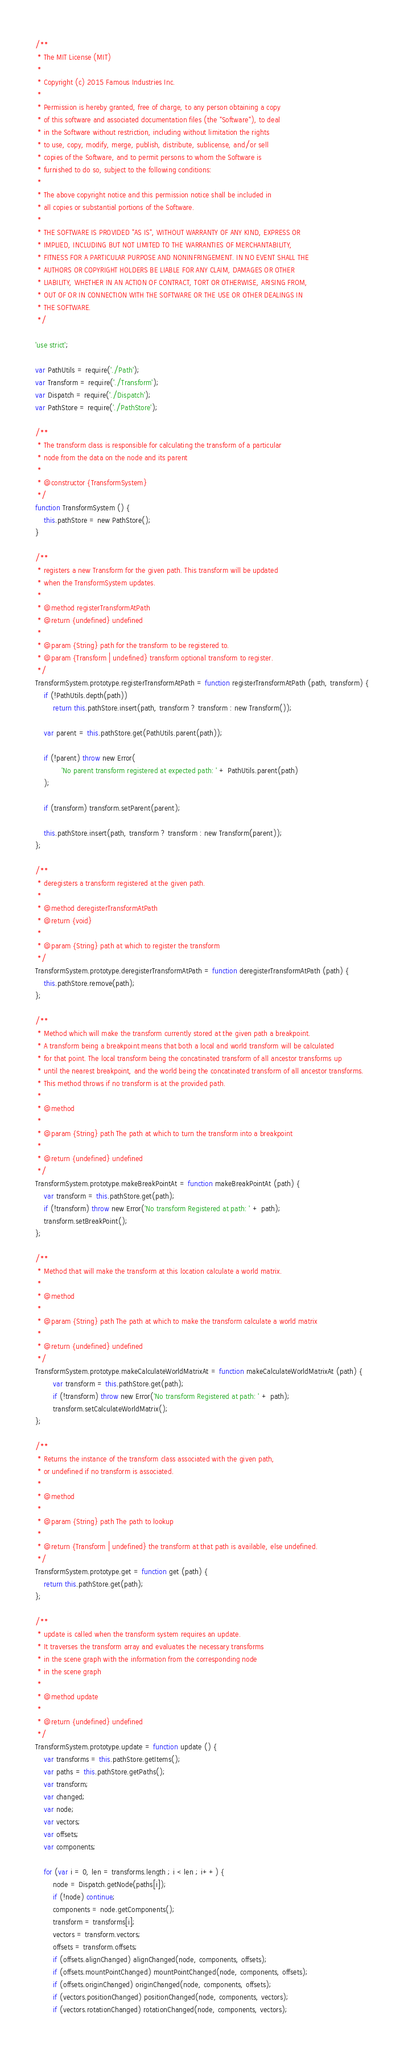<code> <loc_0><loc_0><loc_500><loc_500><_JavaScript_>/**
 * The MIT License (MIT)
 * 
 * Copyright (c) 2015 Famous Industries Inc.
 * 
 * Permission is hereby granted, free of charge, to any person obtaining a copy
 * of this software and associated documentation files (the "Software"), to deal
 * in the Software without restriction, including without limitation the rights
 * to use, copy, modify, merge, publish, distribute, sublicense, and/or sell
 * copies of the Software, and to permit persons to whom the Software is
 * furnished to do so, subject to the following conditions:
 * 
 * The above copyright notice and this permission notice shall be included in
 * all copies or substantial portions of the Software.
 * 
 * THE SOFTWARE IS PROVIDED "AS IS", WITHOUT WARRANTY OF ANY KIND, EXPRESS OR
 * IMPLIED, INCLUDING BUT NOT LIMITED TO THE WARRANTIES OF MERCHANTABILITY,
 * FITNESS FOR A PARTICULAR PURPOSE AND NONINFRINGEMENT. IN NO EVENT SHALL THE
 * AUTHORS OR COPYRIGHT HOLDERS BE LIABLE FOR ANY CLAIM, DAMAGES OR OTHER
 * LIABILITY, WHETHER IN AN ACTION OF CONTRACT, TORT OR OTHERWISE, ARISING FROM,
 * OUT OF OR IN CONNECTION WITH THE SOFTWARE OR THE USE OR OTHER DEALINGS IN
 * THE SOFTWARE.
 */

'use strict';

var PathUtils = require('./Path');
var Transform = require('./Transform');
var Dispatch = require('./Dispatch');
var PathStore = require('./PathStore');

/**
 * The transform class is responsible for calculating the transform of a particular
 * node from the data on the node and its parent
 *
 * @constructor {TransformSystem}
 */
function TransformSystem () {
    this.pathStore = new PathStore();
}

/**
 * registers a new Transform for the given path. This transform will be updated
 * when the TransformSystem updates.
 *
 * @method registerTransformAtPath
 * @return {undefined} undefined
 *
 * @param {String} path for the transform to be registered to.
 * @param {Transform | undefined} transform optional transform to register.
 */
TransformSystem.prototype.registerTransformAtPath = function registerTransformAtPath (path, transform) {
    if (!PathUtils.depth(path))
        return this.pathStore.insert(path, transform ? transform : new Transform());

    var parent = this.pathStore.get(PathUtils.parent(path));

    if (!parent) throw new Error(
            'No parent transform registered at expected path: ' + PathUtils.parent(path)
    );

    if (transform) transform.setParent(parent);

    this.pathStore.insert(path, transform ? transform : new Transform(parent));
};

/**
 * deregisters a transform registered at the given path.
 *
 * @method deregisterTransformAtPath
 * @return {void}
 *
 * @param {String} path at which to register the transform
 */
TransformSystem.prototype.deregisterTransformAtPath = function deregisterTransformAtPath (path) {
    this.pathStore.remove(path);
};

/**
 * Method which will make the transform currently stored at the given path a breakpoint.
 * A transform being a breakpoint means that both a local and world transform will be calculated
 * for that point. The local transform being the concatinated transform of all ancestor transforms up
 * until the nearest breakpoint, and the world being the concatinated transform of all ancestor transforms.
 * This method throws if no transform is at the provided path.
 *
 * @method
 *
 * @param {String} path The path at which to turn the transform into a breakpoint
 *
 * @return {undefined} undefined
 */
TransformSystem.prototype.makeBreakPointAt = function makeBreakPointAt (path) {
    var transform = this.pathStore.get(path);
    if (!transform) throw new Error('No transform Registered at path: ' + path);
    transform.setBreakPoint();
};

/**
 * Method that will make the transform at this location calculate a world matrix.
 *
 * @method
 *
 * @param {String} path The path at which to make the transform calculate a world matrix
 *
 * @return {undefined} undefined
 */
TransformSystem.prototype.makeCalculateWorldMatrixAt = function makeCalculateWorldMatrixAt (path) {
        var transform = this.pathStore.get(path);
        if (!transform) throw new Error('No transform Registered at path: ' + path);
        transform.setCalculateWorldMatrix();
};

/**
 * Returns the instance of the transform class associated with the given path,
 * or undefined if no transform is associated.
 *
 * @method
 * 
 * @param {String} path The path to lookup
 *
 * @return {Transform | undefined} the transform at that path is available, else undefined.
 */
TransformSystem.prototype.get = function get (path) {
    return this.pathStore.get(path);
};

/**
 * update is called when the transform system requires an update.
 * It traverses the transform array and evaluates the necessary transforms
 * in the scene graph with the information from the corresponding node
 * in the scene graph
 *
 * @method update
 *
 * @return {undefined} undefined
 */
TransformSystem.prototype.update = function update () {
    var transforms = this.pathStore.getItems();
    var paths = this.pathStore.getPaths();
    var transform;
    var changed;
    var node;
    var vectors;
    var offsets;
    var components;

    for (var i = 0, len = transforms.length ; i < len ; i++) {
        node = Dispatch.getNode(paths[i]);
        if (!node) continue;
        components = node.getComponents();
        transform = transforms[i];
        vectors = transform.vectors;
        offsets = transform.offsets;
        if (offsets.alignChanged) alignChanged(node, components, offsets);
        if (offsets.mountPointChanged) mountPointChanged(node, components, offsets);
        if (offsets.originChanged) originChanged(node, components, offsets);
        if (vectors.positionChanged) positionChanged(node, components, vectors);
        if (vectors.rotationChanged) rotationChanged(node, components, vectors);</code> 